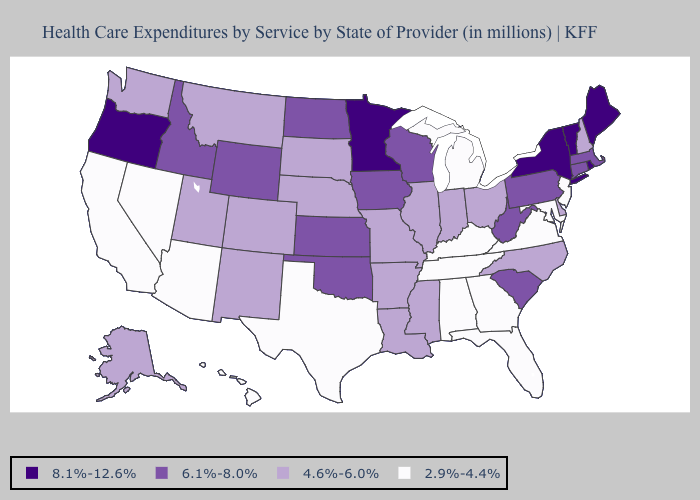What is the value of Oklahoma?
Write a very short answer. 6.1%-8.0%. Name the states that have a value in the range 2.9%-4.4%?
Short answer required. Alabama, Arizona, California, Florida, Georgia, Hawaii, Kentucky, Maryland, Michigan, Nevada, New Jersey, Tennessee, Texas, Virginia. Name the states that have a value in the range 4.6%-6.0%?
Answer briefly. Alaska, Arkansas, Colorado, Delaware, Illinois, Indiana, Louisiana, Mississippi, Missouri, Montana, Nebraska, New Hampshire, New Mexico, North Carolina, Ohio, South Dakota, Utah, Washington. Among the states that border New Mexico , does Texas have the lowest value?
Short answer required. Yes. Among the states that border Wyoming , which have the lowest value?
Keep it brief. Colorado, Montana, Nebraska, South Dakota, Utah. What is the value of Missouri?
Write a very short answer. 4.6%-6.0%. Among the states that border Delaware , which have the highest value?
Concise answer only. Pennsylvania. Name the states that have a value in the range 8.1%-12.6%?
Concise answer only. Maine, Minnesota, New York, Oregon, Rhode Island, Vermont. Does Vermont have the highest value in the USA?
Write a very short answer. Yes. Does the map have missing data?
Concise answer only. No. Does Virginia have the same value as Maine?
Write a very short answer. No. Does Alaska have the same value as Colorado?
Write a very short answer. Yes. What is the value of Indiana?
Concise answer only. 4.6%-6.0%. Name the states that have a value in the range 4.6%-6.0%?
Short answer required. Alaska, Arkansas, Colorado, Delaware, Illinois, Indiana, Louisiana, Mississippi, Missouri, Montana, Nebraska, New Hampshire, New Mexico, North Carolina, Ohio, South Dakota, Utah, Washington. What is the lowest value in the MidWest?
Short answer required. 2.9%-4.4%. 